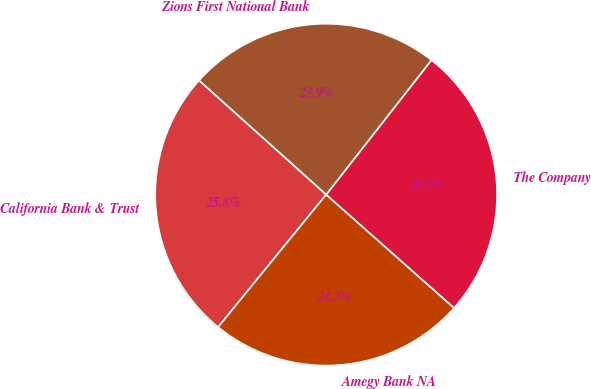<chart> <loc_0><loc_0><loc_500><loc_500><pie_chart><fcel>The Company<fcel>Zions First National Bank<fcel>California Bank & Trust<fcel>Amegy Bank NA<nl><fcel>25.98%<fcel>23.92%<fcel>25.76%<fcel>24.34%<nl></chart> 